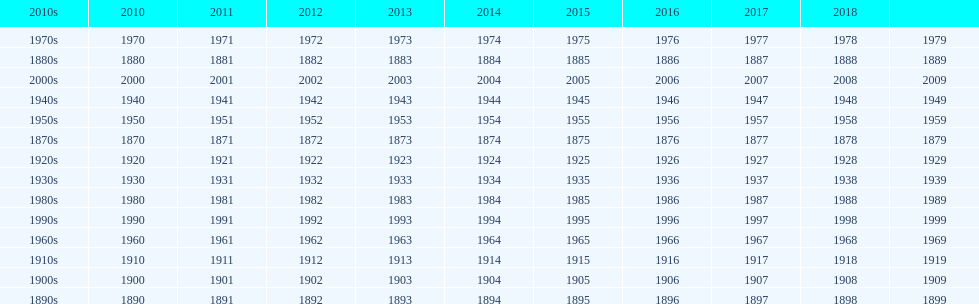What is the earliest year that a film was released? 1870. 